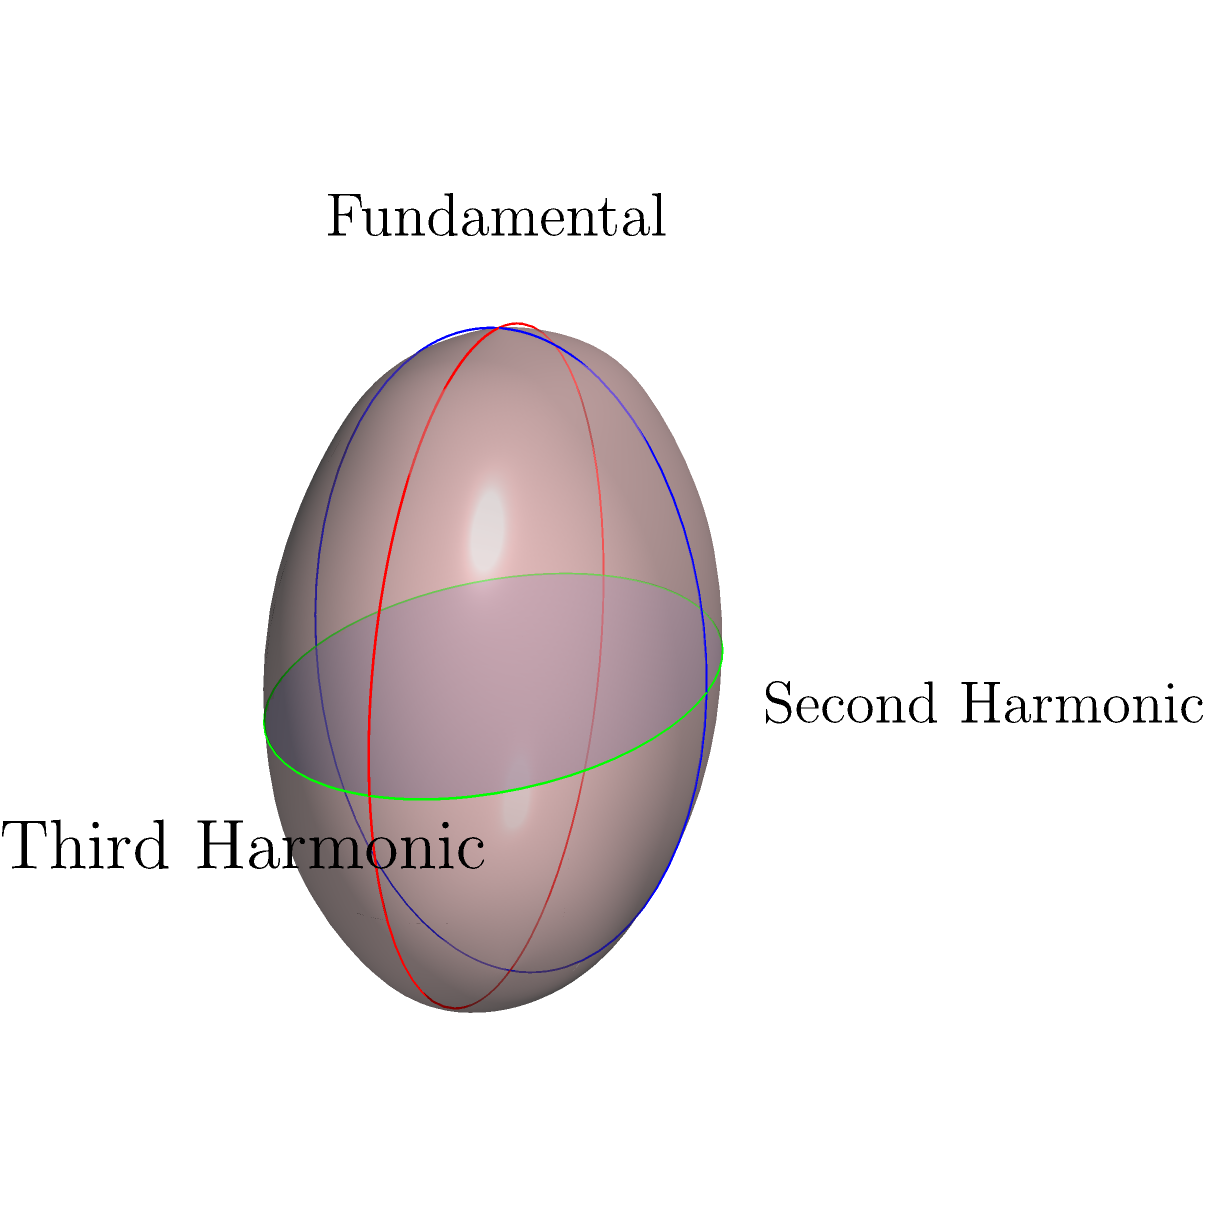In the spherical representation of harmonic structures for theremin music, how does the relationship between the fundamental frequency and its harmonics change compared to traditional Euclidean representations? Consider the great circles shown in the diagram. To understand the relationship between the fundamental frequency and its harmonics in spherical geometry for theremin music, let's follow these steps:

1. In traditional Euclidean representations, harmonics are often visualized as integer multiples of the fundamental frequency on a straight line.

2. In spherical geometry, we represent the fundamental frequency and its harmonics as great circles on a sphere:
   - The blue circle (X-axis) represents the third harmonic
   - The red circle (Y-axis) represents the second harmonic
   - The green circle (Z-axis) represents the fundamental frequency

3. In this spherical representation:
   - The fundamental frequency and its harmonics are equidistant from the center of the sphere.
   - The angles between these great circles represent the relationships between the frequencies.

4. Key differences from Euclidean representation:
   - Instead of linear relationships, we have angular relationships.
   - The "distance" between harmonics is measured in terms of arc length along the sphere's surface.
   - Higher harmonics don't extend infinitely but wrap around the sphere.

5. This spherical representation allows for:
   - Cyclic nature of octaves (as you go around the sphere, you return to the starting point)
   - Equal importance to all harmonics (all are equidistant from the center)
   - Novel ways to visualize and manipulate harmonic relationships in theremin music

6. For a theremin producer, this representation could inspire new ways of thinking about harmonic structures:
   - Composition based on spherical movements rather than linear progressions
   - Exploration of harmonic relationships based on great circle intersections
   - Creation of unique timbres by manipulating the angles between harmonics

In summary, the spherical representation transforms the linear, Euclidean concept of harmonics into a cyclic, angular relationship, offering new perspectives for theremin music composition and sound design.
Answer: Cyclic, angular relationships replace linear, infinite progression 